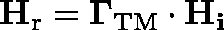<formula> <loc_0><loc_0><loc_500><loc_500>H _ { r } = \Gamma _ { T M } \cdot H _ { i }</formula> 